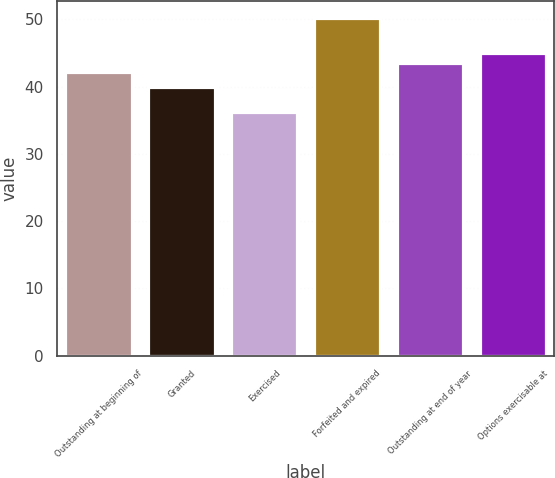<chart> <loc_0><loc_0><loc_500><loc_500><bar_chart><fcel>Outstanding at beginning of<fcel>Granted<fcel>Exercised<fcel>Forfeited and expired<fcel>Outstanding at end of year<fcel>Options exercisable at<nl><fcel>42.17<fcel>39.99<fcel>36.24<fcel>50.2<fcel>43.57<fcel>44.97<nl></chart> 